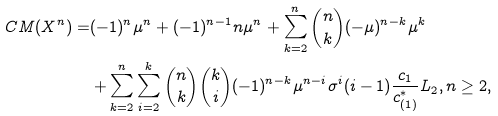<formula> <loc_0><loc_0><loc_500><loc_500>C M ( X ^ { n } ) = & ( - 1 ) ^ { n } \mu ^ { n } + ( - 1 ) ^ { n - 1 } n \mu ^ { n } + \sum _ { k = 2 } ^ { n } \binom { n } { k } ( - \mu ) ^ { n - k } \mu ^ { k } \\ & + \sum _ { k = 2 } ^ { n } \sum _ { i = 2 } ^ { k } \binom { n } { k } \binom { k } { i } ( - 1 ) ^ { n - k } \mu ^ { n - i } \sigma ^ { i } ( i - 1 ) \frac { c _ { 1 } } { c _ { ( 1 ) } ^ { \ast } } L _ { 2 } , n \geq 2 ,</formula> 